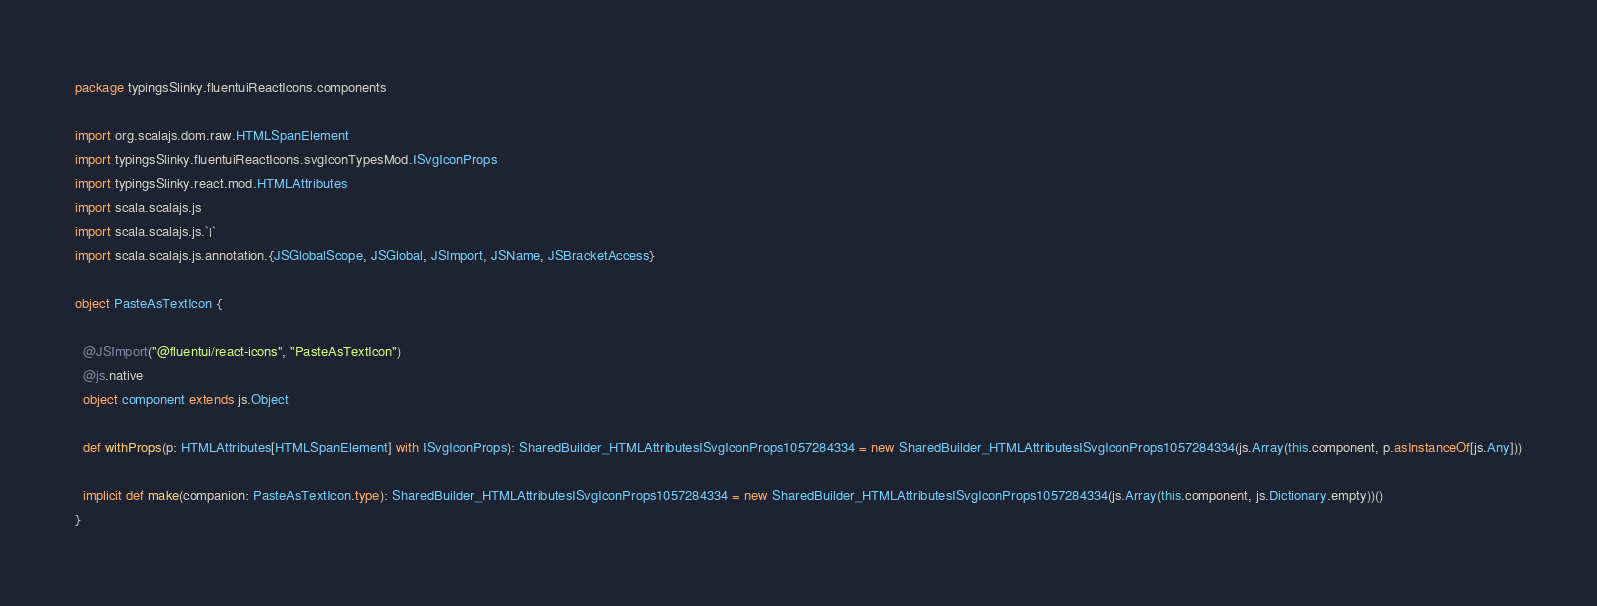Convert code to text. <code><loc_0><loc_0><loc_500><loc_500><_Scala_>package typingsSlinky.fluentuiReactIcons.components

import org.scalajs.dom.raw.HTMLSpanElement
import typingsSlinky.fluentuiReactIcons.svgIconTypesMod.ISvgIconProps
import typingsSlinky.react.mod.HTMLAttributes
import scala.scalajs.js
import scala.scalajs.js.`|`
import scala.scalajs.js.annotation.{JSGlobalScope, JSGlobal, JSImport, JSName, JSBracketAccess}

object PasteAsTextIcon {
  
  @JSImport("@fluentui/react-icons", "PasteAsTextIcon")
  @js.native
  object component extends js.Object
  
  def withProps(p: HTMLAttributes[HTMLSpanElement] with ISvgIconProps): SharedBuilder_HTMLAttributesISvgIconProps1057284334 = new SharedBuilder_HTMLAttributesISvgIconProps1057284334(js.Array(this.component, p.asInstanceOf[js.Any]))
  
  implicit def make(companion: PasteAsTextIcon.type): SharedBuilder_HTMLAttributesISvgIconProps1057284334 = new SharedBuilder_HTMLAttributesISvgIconProps1057284334(js.Array(this.component, js.Dictionary.empty))()
}
</code> 